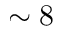Convert formula to latex. <formula><loc_0><loc_0><loc_500><loc_500>\sim 8</formula> 